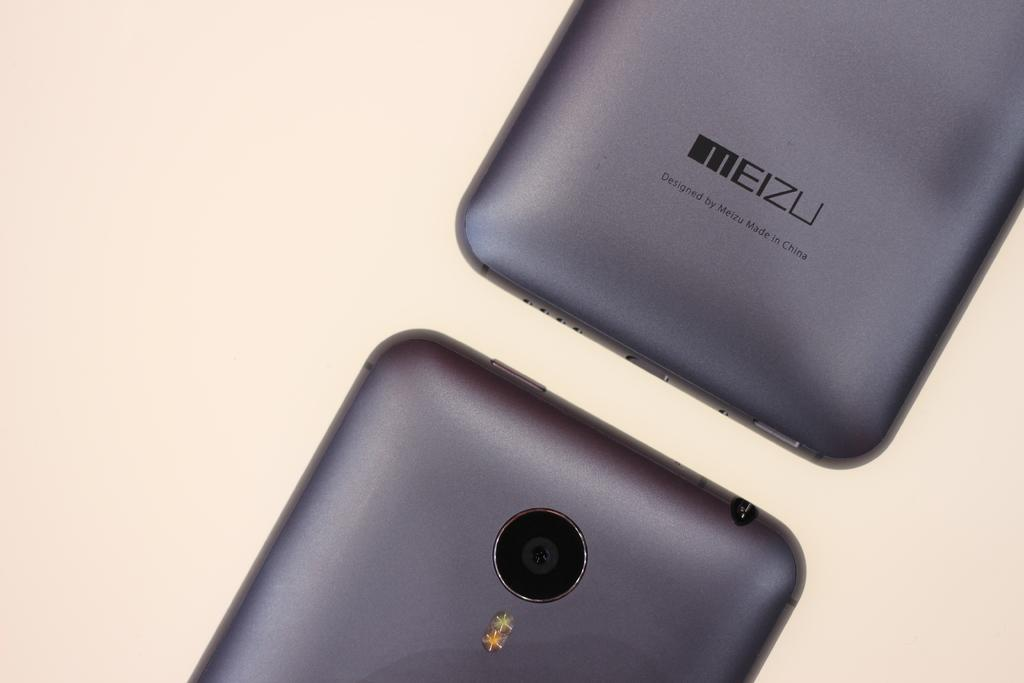<image>
Share a concise interpretation of the image provided. Two gray Meizu cellphones placed with its face down. 